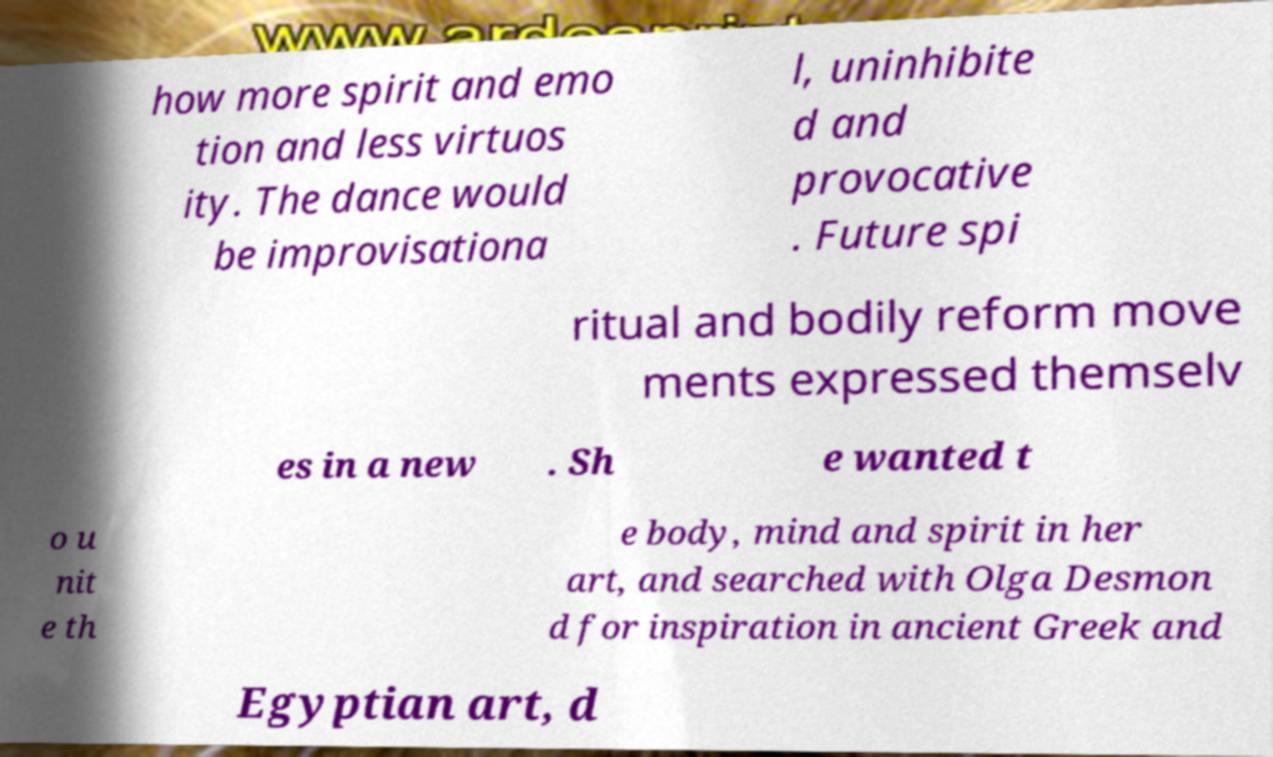Could you extract and type out the text from this image? how more spirit and emo tion and less virtuos ity. The dance would be improvisationa l, uninhibite d and provocative . Future spi ritual and bodily reform move ments expressed themselv es in a new . Sh e wanted t o u nit e th e body, mind and spirit in her art, and searched with Olga Desmon d for inspiration in ancient Greek and Egyptian art, d 